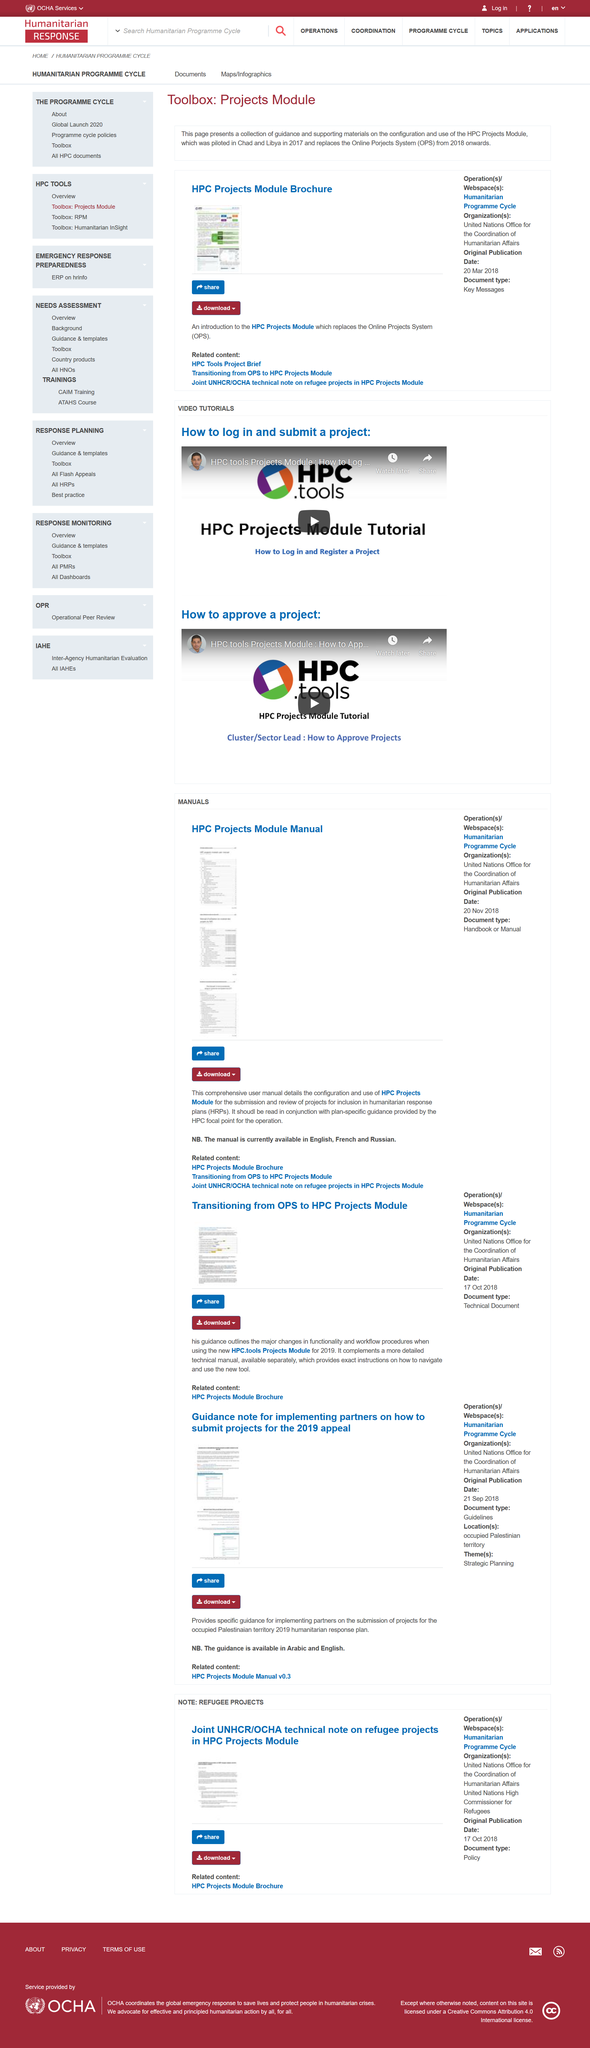Outline some significant characteristics in this image. It is recommended that the comprehensive user manual be read in conjunction with the plan-specific guidance provided by the HPC focal point for the operation, in order to fully understand the usage and requirements of the High Performance Computing service. This page contains three links to related content. The language of the manual is English, French, and Russian. 